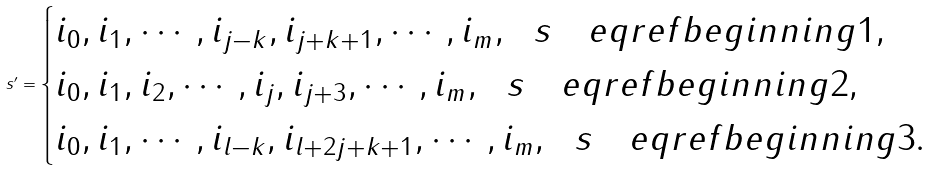Convert formula to latex. <formula><loc_0><loc_0><loc_500><loc_500>s ^ { \prime } = \begin{cases} i _ { 0 } , i _ { 1 } , \cdots , i _ { j - k } , i _ { j + k + 1 } , \cdots , i _ { m } , \ \ s \quad e q r e f { b e g i n n i n g 1 } , \\ i _ { 0 } , i _ { 1 } , i _ { 2 } , \cdots , i _ { j } , i _ { j + 3 } , \cdots , i _ { m } , \ \ s \quad e q r e f { b e g i n n i n g 2 } , \\ i _ { 0 } , i _ { 1 } , \cdots , i _ { l - k } , i _ { l + 2 j + k + 1 } , \cdots , i _ { m } , \ \ s \quad e q r e f { b e g i n n i n g 3 } . \end{cases}</formula> 